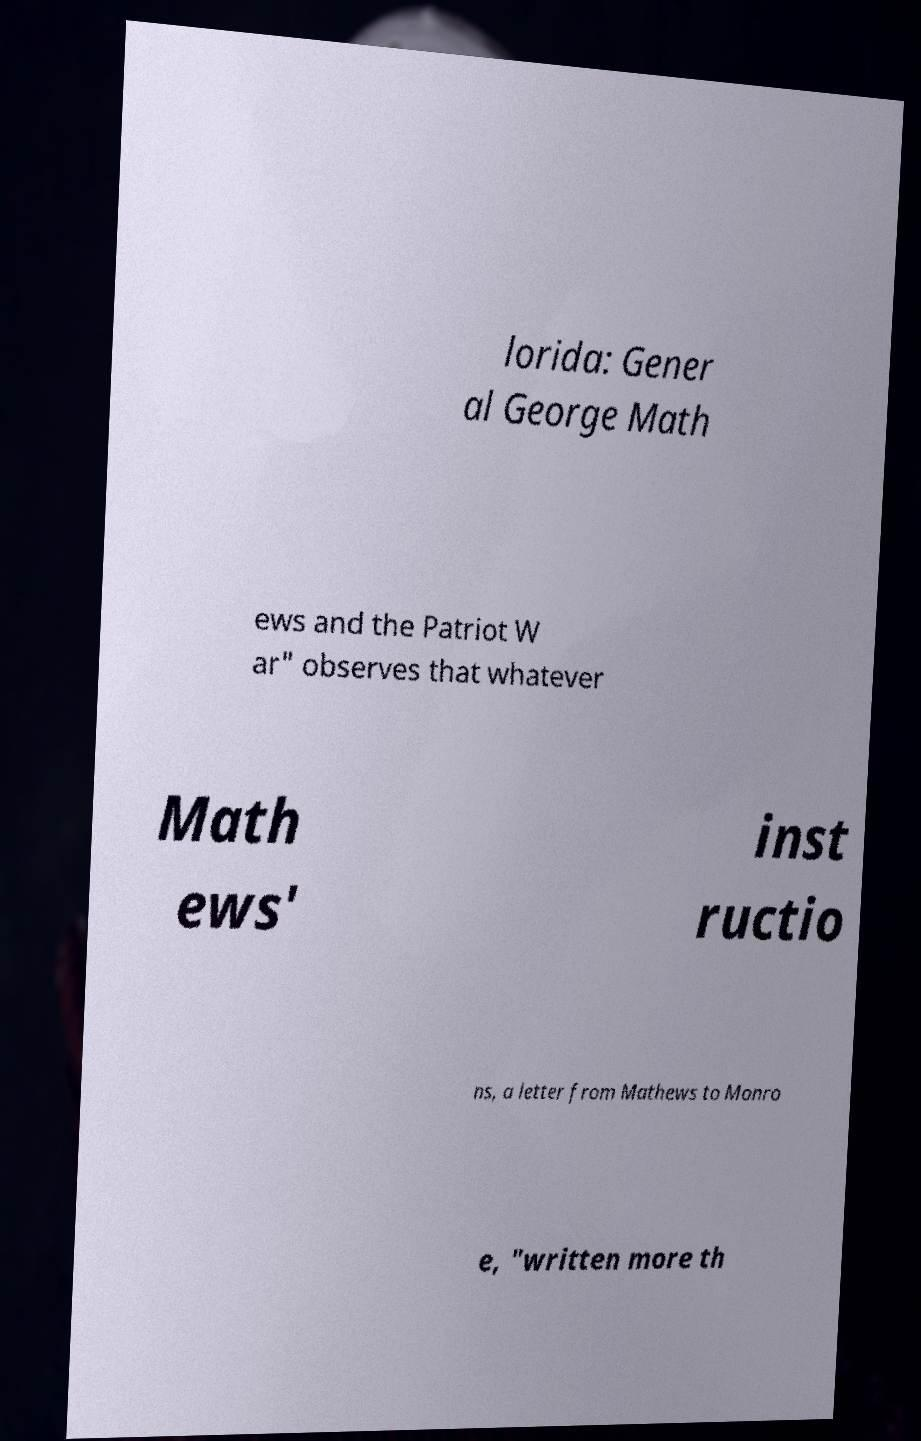Please identify and transcribe the text found in this image. lorida: Gener al George Math ews and the Patriot W ar" observes that whatever Math ews' inst ructio ns, a letter from Mathews to Monro e, "written more th 